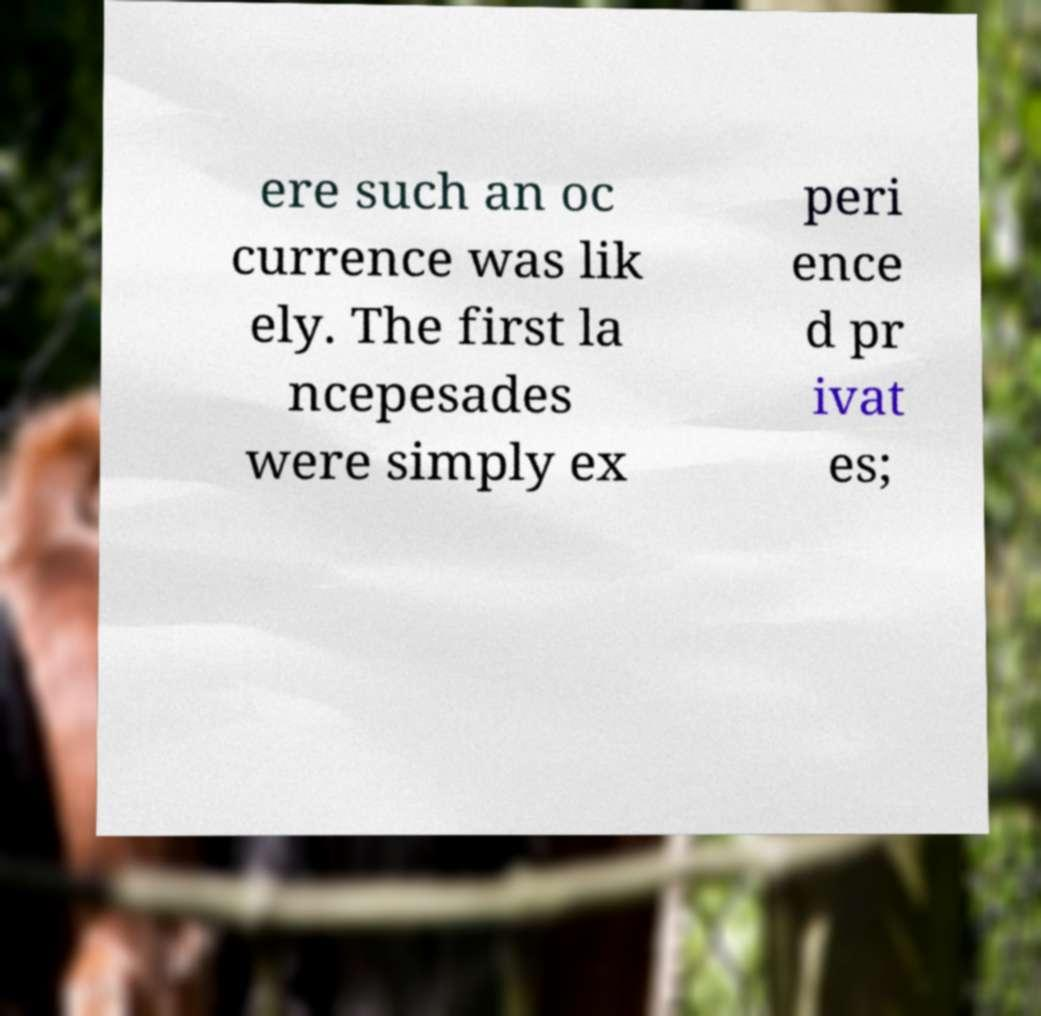There's text embedded in this image that I need extracted. Can you transcribe it verbatim? ere such an oc currence was lik ely. The first la ncepesades were simply ex peri ence d pr ivat es; 